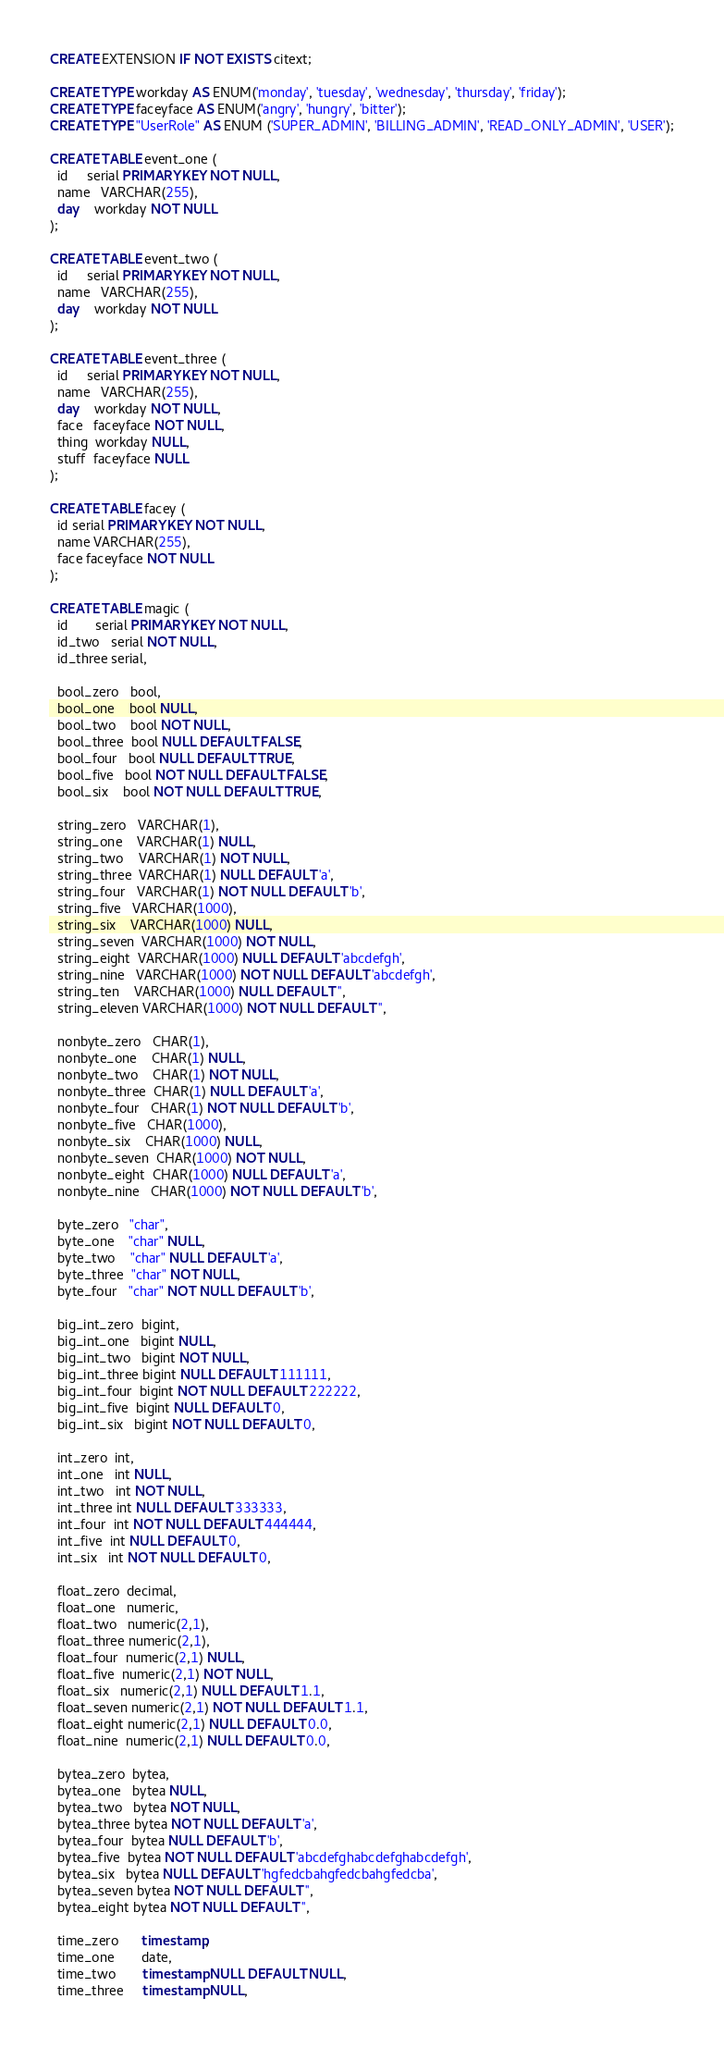<code> <loc_0><loc_0><loc_500><loc_500><_SQL_>CREATE EXTENSION IF NOT EXISTS citext;

CREATE TYPE workday AS ENUM('monday', 'tuesday', 'wednesday', 'thursday', 'friday');
CREATE TYPE faceyface AS ENUM('angry', 'hungry', 'bitter');
CREATE TYPE "UserRole" AS ENUM ('SUPER_ADMIN', 'BILLING_ADMIN', 'READ_ONLY_ADMIN', 'USER');

CREATE TABLE event_one (
  id     serial PRIMARY KEY NOT NULL,
  name   VARCHAR(255),
  day    workday NOT NULL
);

CREATE TABLE event_two (
  id     serial PRIMARY KEY NOT NULL,
  name   VARCHAR(255),
  day    workday NOT NULL
);

CREATE TABLE event_three (
  id     serial PRIMARY KEY NOT NULL,
  name   VARCHAR(255),
  day    workday NOT NULL,
  face   faceyface NOT NULL,
  thing  workday NULL,
  stuff  faceyface NULL
);

CREATE TABLE facey (
  id serial PRIMARY KEY NOT NULL,
  name VARCHAR(255),
  face faceyface NOT NULL
);

CREATE TABLE magic (
  id       serial PRIMARY KEY NOT NULL,
  id_two   serial NOT NULL,
  id_three serial,

  bool_zero   bool,
  bool_one    bool NULL,
  bool_two    bool NOT NULL,
  bool_three  bool NULL DEFAULT FALSE,
  bool_four   bool NULL DEFAULT TRUE,
  bool_five   bool NOT NULL DEFAULT FALSE,
  bool_six    bool NOT NULL DEFAULT TRUE,

  string_zero   VARCHAR(1),
  string_one    VARCHAR(1) NULL,
  string_two    VARCHAR(1) NOT NULL,
  string_three  VARCHAR(1) NULL DEFAULT 'a',
  string_four   VARCHAR(1) NOT NULL DEFAULT 'b',
  string_five   VARCHAR(1000),
  string_six    VARCHAR(1000) NULL,
  string_seven  VARCHAR(1000) NOT NULL,
  string_eight  VARCHAR(1000) NULL DEFAULT 'abcdefgh',
  string_nine   VARCHAR(1000) NOT NULL DEFAULT 'abcdefgh',
  string_ten    VARCHAR(1000) NULL DEFAULT '',
  string_eleven VARCHAR(1000) NOT NULL DEFAULT '',

  nonbyte_zero   CHAR(1),
  nonbyte_one    CHAR(1) NULL,
  nonbyte_two    CHAR(1) NOT NULL,
  nonbyte_three  CHAR(1) NULL DEFAULT 'a',
  nonbyte_four   CHAR(1) NOT NULL DEFAULT 'b',
  nonbyte_five   CHAR(1000),
  nonbyte_six    CHAR(1000) NULL,
  nonbyte_seven  CHAR(1000) NOT NULL,
  nonbyte_eight  CHAR(1000) NULL DEFAULT 'a',
  nonbyte_nine   CHAR(1000) NOT NULL DEFAULT 'b',

  byte_zero   "char",
  byte_one    "char" NULL,
  byte_two    "char" NULL DEFAULT 'a',
  byte_three  "char" NOT NULL,
  byte_four   "char" NOT NULL DEFAULT 'b',

  big_int_zero  bigint,
  big_int_one   bigint NULL,
  big_int_two   bigint NOT NULL,
  big_int_three bigint NULL DEFAULT 111111,
  big_int_four  bigint NOT NULL DEFAULT 222222,
  big_int_five  bigint NULL DEFAULT 0,
  big_int_six   bigint NOT NULL DEFAULT 0,

  int_zero  int,
  int_one   int NULL,
  int_two   int NOT NULL,
  int_three int NULL DEFAULT 333333,
  int_four  int NOT NULL DEFAULT 444444,
  int_five  int NULL DEFAULT 0,
  int_six   int NOT NULL DEFAULT 0,

  float_zero  decimal,
  float_one   numeric,
  float_two   numeric(2,1),
  float_three numeric(2,1),
  float_four  numeric(2,1) NULL,
  float_five  numeric(2,1) NOT NULL,
  float_six   numeric(2,1) NULL DEFAULT 1.1,
  float_seven numeric(2,1) NOT NULL DEFAULT 1.1,
  float_eight numeric(2,1) NULL DEFAULT 0.0,
  float_nine  numeric(2,1) NULL DEFAULT 0.0,

  bytea_zero  bytea,
  bytea_one   bytea NULL,
  bytea_two   bytea NOT NULL,
  bytea_three bytea NOT NULL DEFAULT 'a',
  bytea_four  bytea NULL DEFAULT 'b',
  bytea_five  bytea NOT NULL DEFAULT 'abcdefghabcdefghabcdefgh',
  bytea_six   bytea NULL DEFAULT 'hgfedcbahgfedcbahgfedcba',
  bytea_seven bytea NOT NULL DEFAULT '',
  bytea_eight bytea NOT NULL DEFAULT '',

  time_zero      timestamp,
  time_one       date,
  time_two       timestamp NULL DEFAULT NULL,
  time_three     timestamp NULL,</code> 